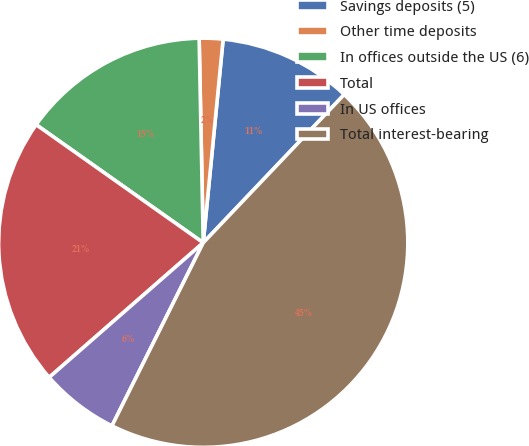Convert chart to OTSL. <chart><loc_0><loc_0><loc_500><loc_500><pie_chart><fcel>Savings deposits (5)<fcel>Other time deposits<fcel>In offices outside the US (6)<fcel>Total<fcel>In US offices<fcel>Total interest-bearing<nl><fcel>10.55%<fcel>1.87%<fcel>14.89%<fcel>21.22%<fcel>6.21%<fcel>45.26%<nl></chart> 